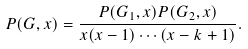Convert formula to latex. <formula><loc_0><loc_0><loc_500><loc_500>P ( G , x ) = { \frac { P ( G _ { 1 } , x ) P ( G _ { 2 } , x ) } { x ( x - 1 ) \cdots ( x - k + 1 ) } } .</formula> 